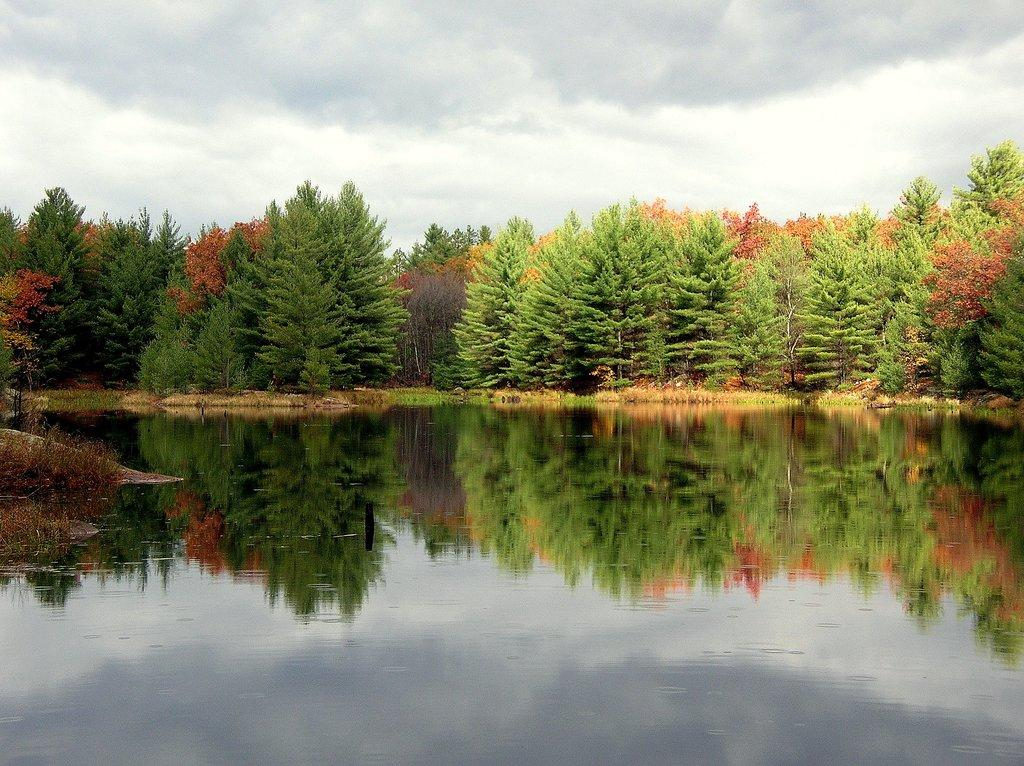What is present at the bottom of the image? There is water at the bottom of the image. What can be seen in the middle of the image? There are trees in the middle of the image. What is visible at the top of the image? The sky is visible at the top of the image. Where is the tray located in the image? There is no tray present in the image. What type of pencil can be seen in the image? There is no pencil present in the image. 